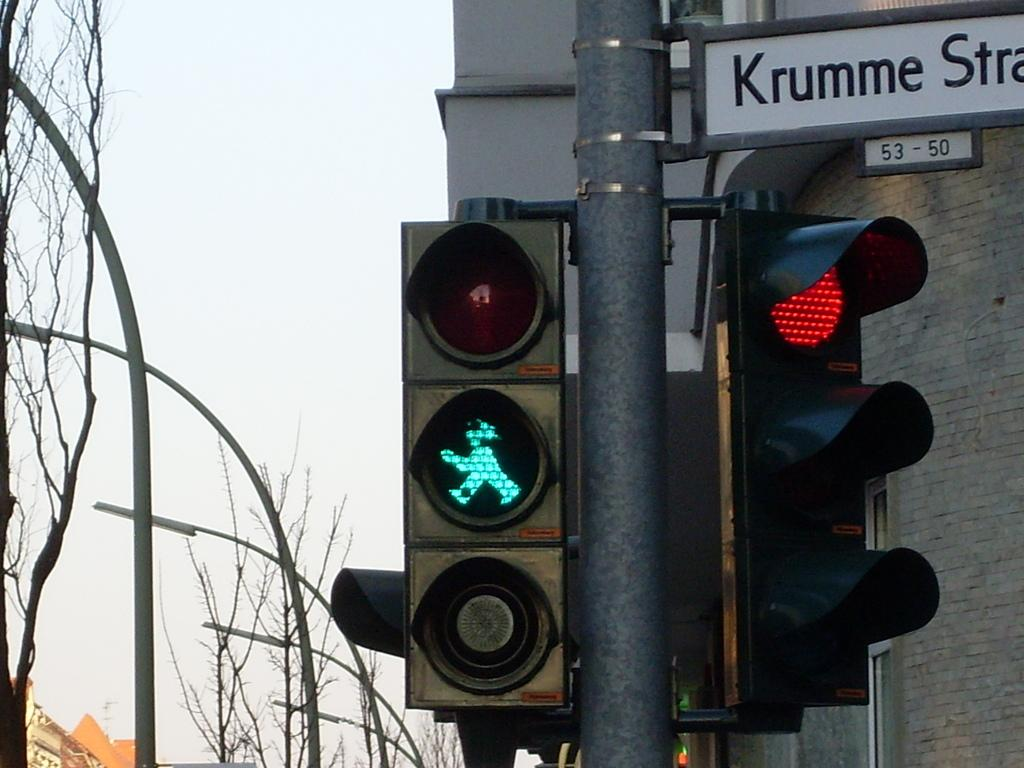<image>
Create a compact narrative representing the image presented. A green crosswalk light next to a street sight that starts with Krumme. 